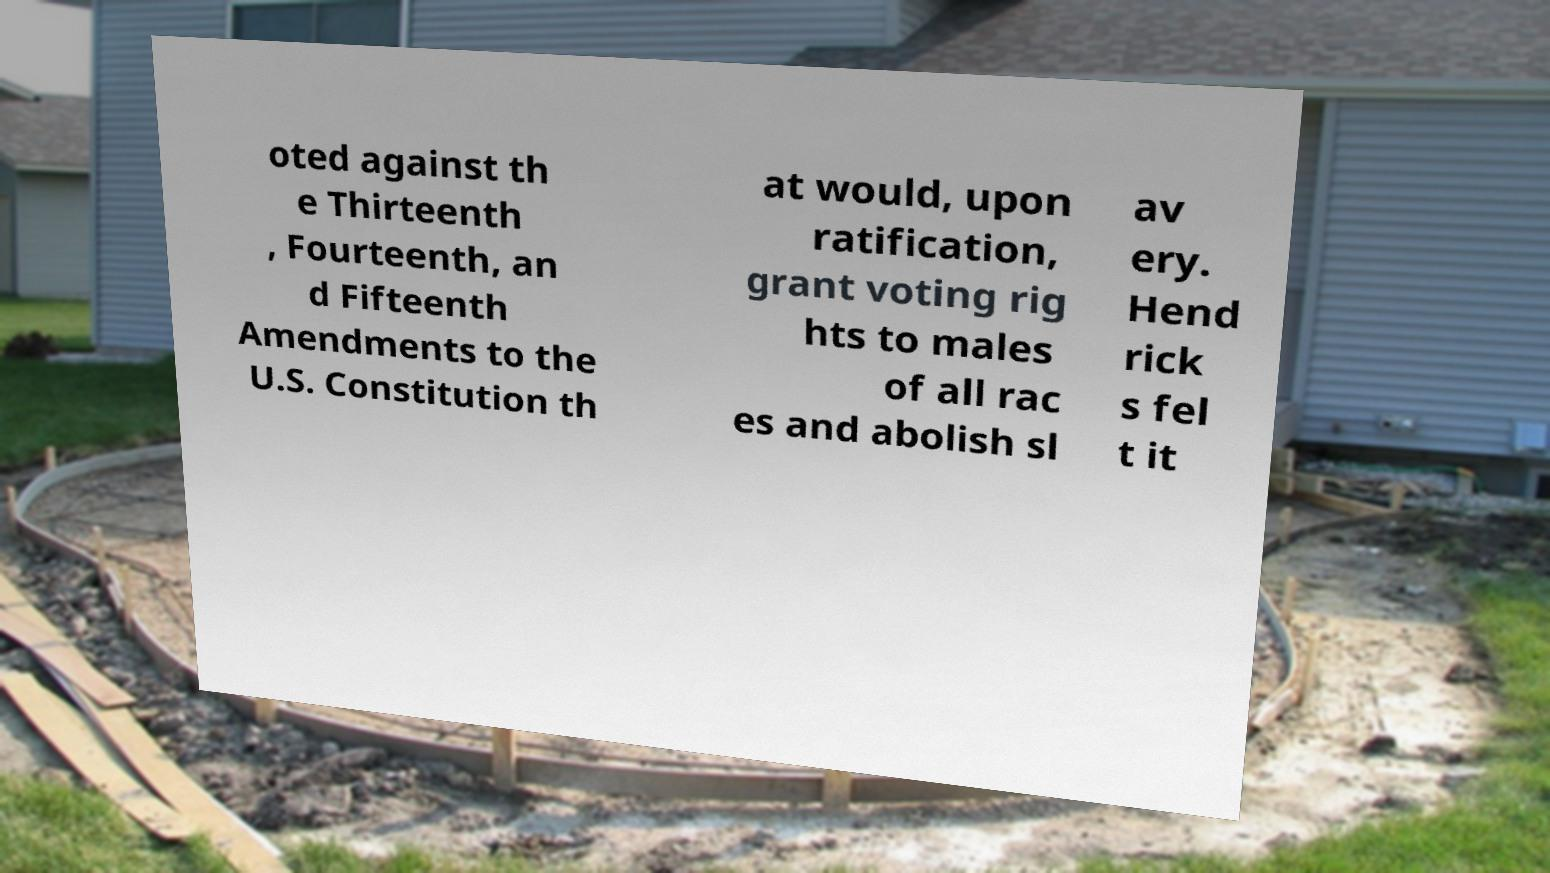Please identify and transcribe the text found in this image. oted against th e Thirteenth , Fourteenth, an d Fifteenth Amendments to the U.S. Constitution th at would, upon ratification, grant voting rig hts to males of all rac es and abolish sl av ery. Hend rick s fel t it 